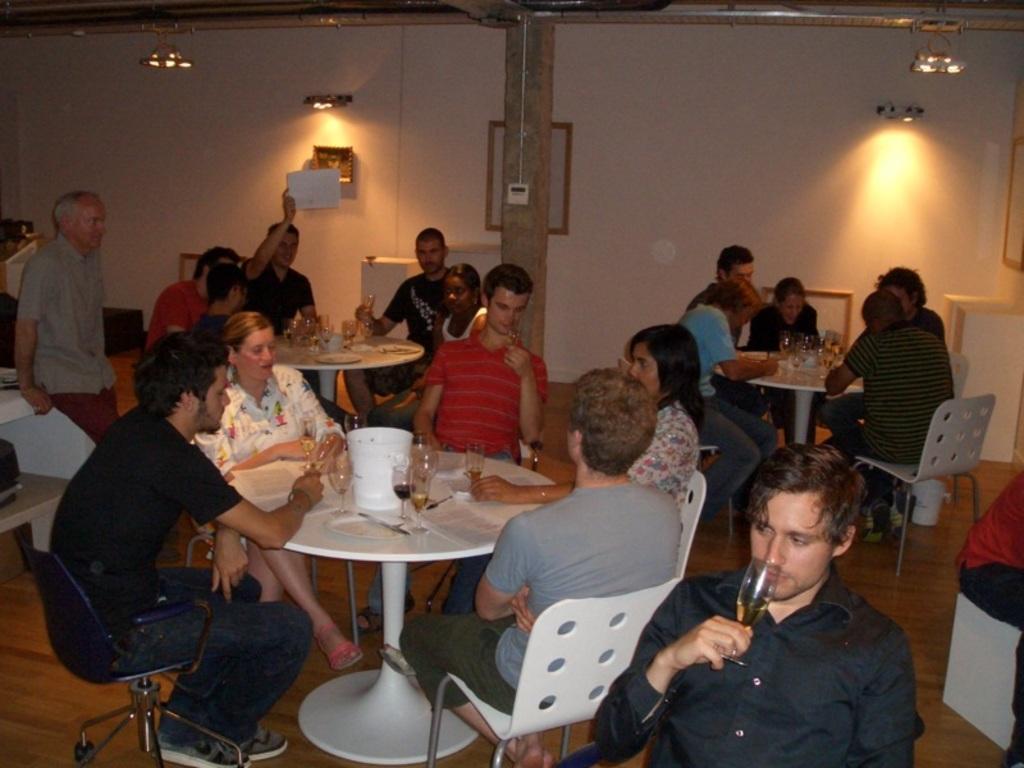How would you summarize this image in a sentence or two? In this image there are group of people sitting on the chairs. This is a white table with wine glasses,small bucket with papers on it. This looks like a pillar with some white object attached to it. These are the lamps and photo frame attached to the wall. Here is the another person standing. These are the white chairs. 